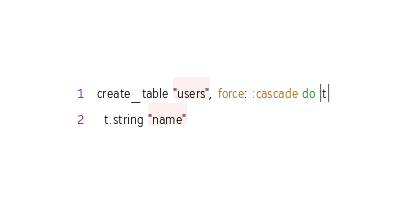<code> <loc_0><loc_0><loc_500><loc_500><_Ruby_>  create_table "users", force: :cascade do |t|
    t.string "name"</code> 